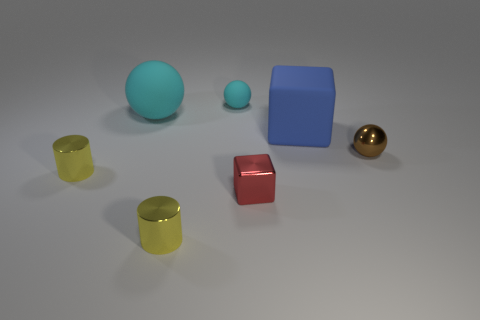There is a metallic cylinder in front of the tiny red metal object; are there any small cyan rubber objects in front of it?
Offer a terse response. No. What is the color of the ball that is the same material as the small cube?
Offer a very short reply. Brown. Are there fewer tiny brown matte balls than metal cylinders?
Your answer should be compact. Yes. What number of cylinders are yellow objects or brown metal things?
Your response must be concise. 2. What number of other matte cubes have the same color as the big block?
Give a very brief answer. 0. What is the size of the ball that is both on the left side of the blue matte cube and in front of the small matte ball?
Offer a terse response. Large. Are there fewer brown spheres that are behind the small rubber sphere than big blue cubes?
Give a very brief answer. Yes. Is the material of the big blue thing the same as the small red thing?
Offer a very short reply. No. How many things are tiny red cubes or metallic cylinders?
Give a very brief answer. 3. What number of objects have the same material as the large block?
Make the answer very short. 2. 